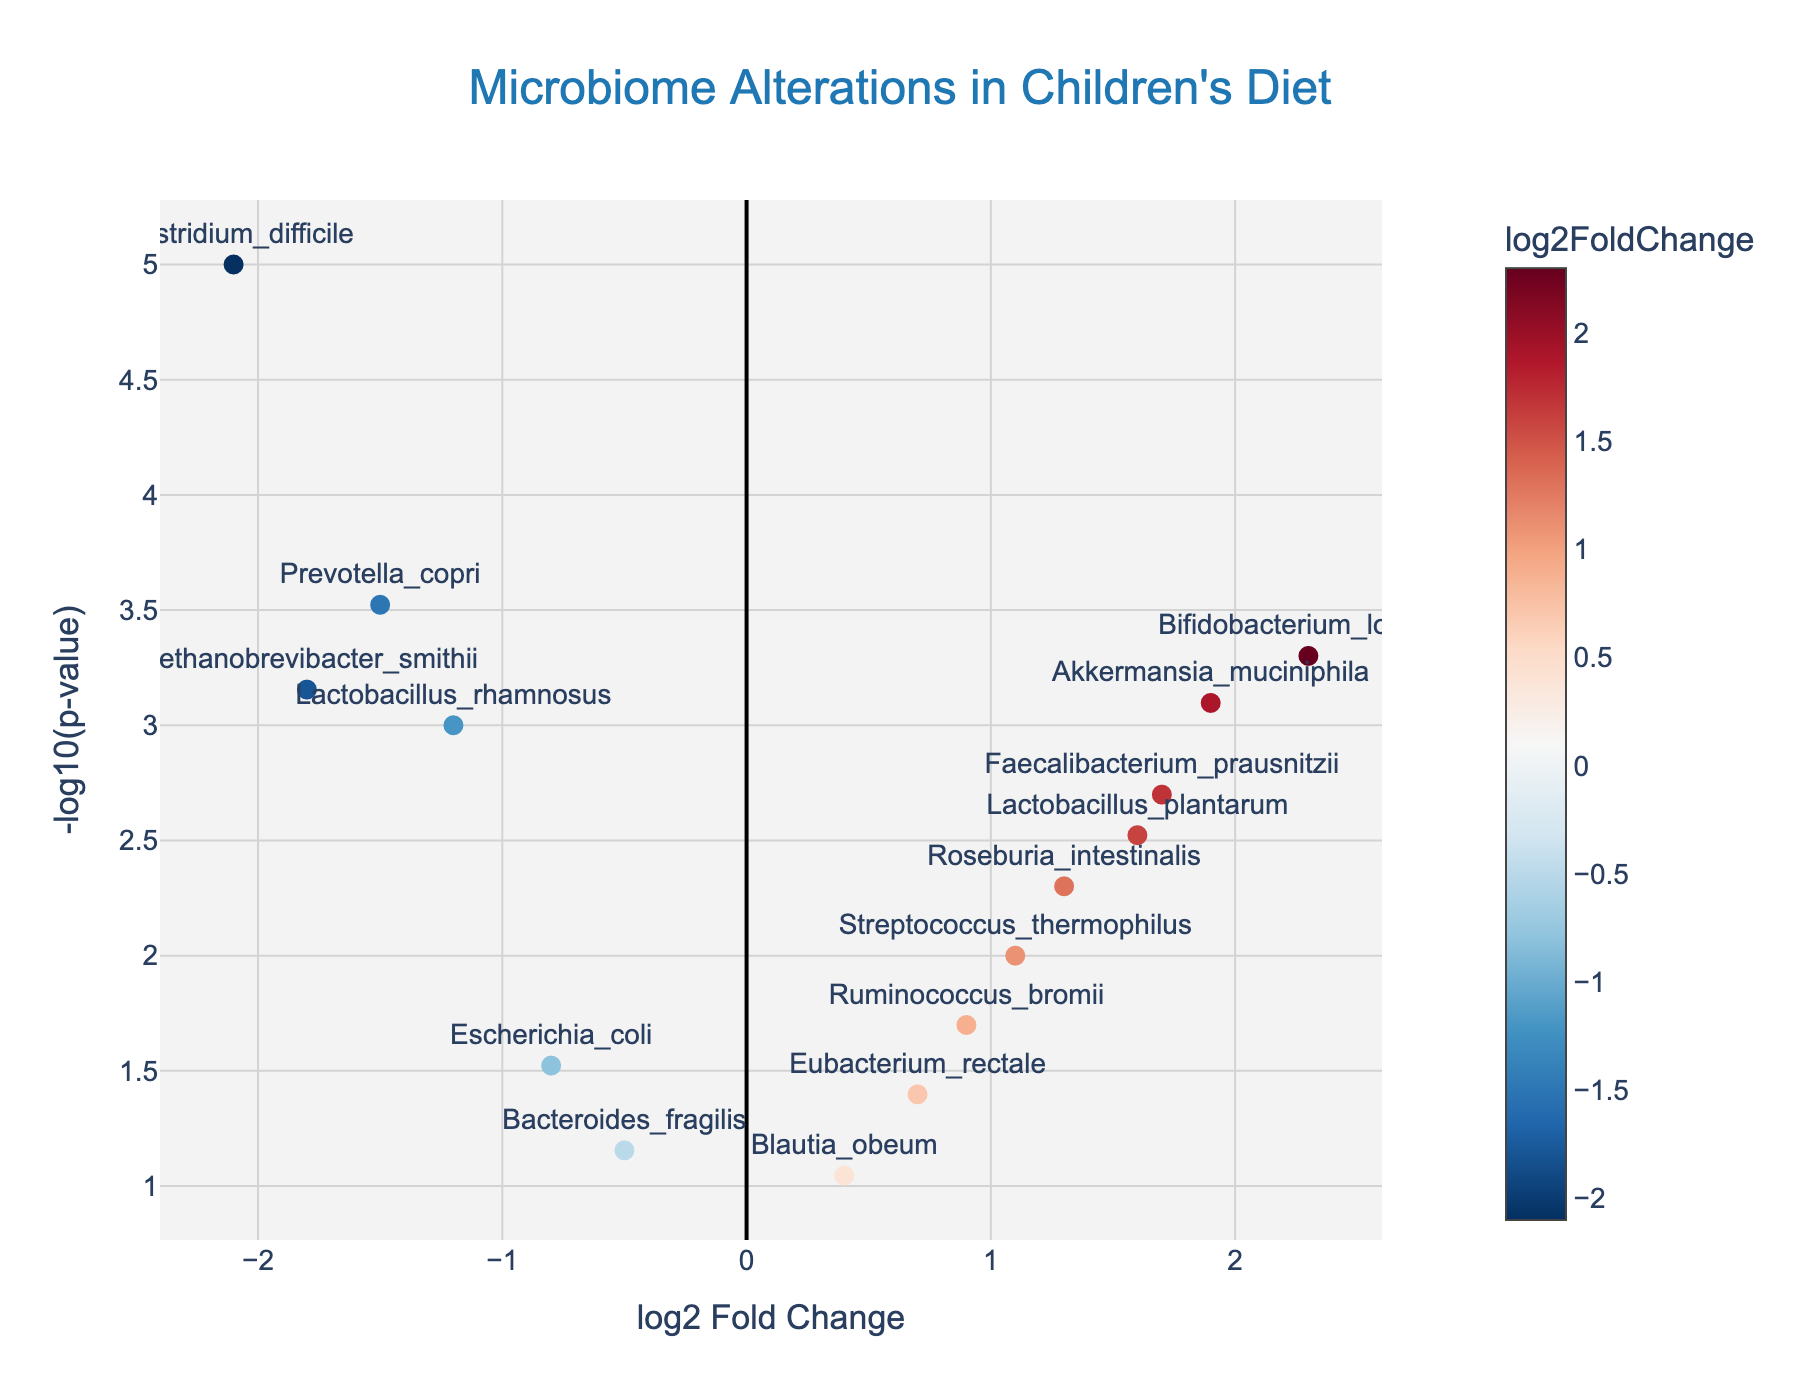How many genes are mentioned in the figure? Count the number of unique gene names displayed in the plot. There are 15 unique gene names displayed in the text annotations and hover texts.
Answer: 15 What is the title of the plot? Look at the top center of the plot to find the title. The title is "Microbiome Alterations in Children's Diet."
Answer: Microbiome Alterations in Children's Diet Which gene has the highest -log10(p-value) and what is its value? Locate the point with the highest y-axis value (-log10(p-value)) and verify its corresponding gene. The gene with the highest -log10(p-value) is Clostridium_difficile, having a log10(p-value) value of -log10(0.00001) = 5.
Answer: Clostridium_difficile, 5 What is the log2 fold change of Lactobacillus_rhamnosus? Find Lactobacillus_rhamnosus in the text annotations or hover texts and check its x-axis value. Lactobacillus_rhamnosus has a log2 fold change of -1.2.
Answer: -1.2 Which genes have a positive log2 fold change and p-values less than 0.01? Look for points in the positive side of the x-axis with y-axis values greater than -log10(0.01). Bifidobacterium_longum, Faecalibacterium_prausnitzii, Akkermansia_muciniphila, Lactobacillus_plantarum, Roseburia_intestinalis.
Answer: Bifidobacterium_longum, Faecalibacterium_prausnitzii, Akkermansia_muciniphila, Lactobacillus_plantarum, Roseburia_intestinalis Which gene has the largest negative log2 fold change? Identify the point found at the lowest negative x-axis value and check its corresponding gene. The gene with the largest negative log2 fold change is Clostridium_difficile with a value of -2.1.
Answer: Clostridium_difficile How many genes have a -log10(p-value) greater than 2? Count the points with y-axis values greater than 2 (i.e., p-values less than 0.01). There are 9 genes: Lactobacillus_rhamnosus, Bifidobacterium_longum, Faecalibacterium_prausnitzii, Akkermansia_muciniphila, Prevotella_copri, Clostridium_difficile, Methanobrevibacter_smithii, Roseburia_intestinalis, Lactobacillus_plantarum.
Answer: 9 Which gene exhibits a -log10(p-value) around 3 and a log2 fold change near 0.9? Find the point close to (0.9, 3) and identify the corresponding gene from the text annotations or hover texts. The gene is Ruminococcus_bromii.
Answer: Ruminococcus_bromii Are there any genes with exactly a log2 fold change of zero? Check the x-axis at zero and see if any points are directly on this line. There are no genes with exactly a log2 fold change of zero in the plot.
Answer: No Which gene is indicated to have a log2 fold change similar to Streptococcus_thermophilus with a slightly better p-value? Compare genes with similar log2 fold changes to Streptococcus_thermophilus (1.1) and find the one with a lower p-value. The gene Roseburia_intestinalis has a log2 fold change of 1.3 and a better p-value.
Answer: Roseburia_intestinalis 